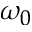Convert formula to latex. <formula><loc_0><loc_0><loc_500><loc_500>\omega _ { 0 }</formula> 